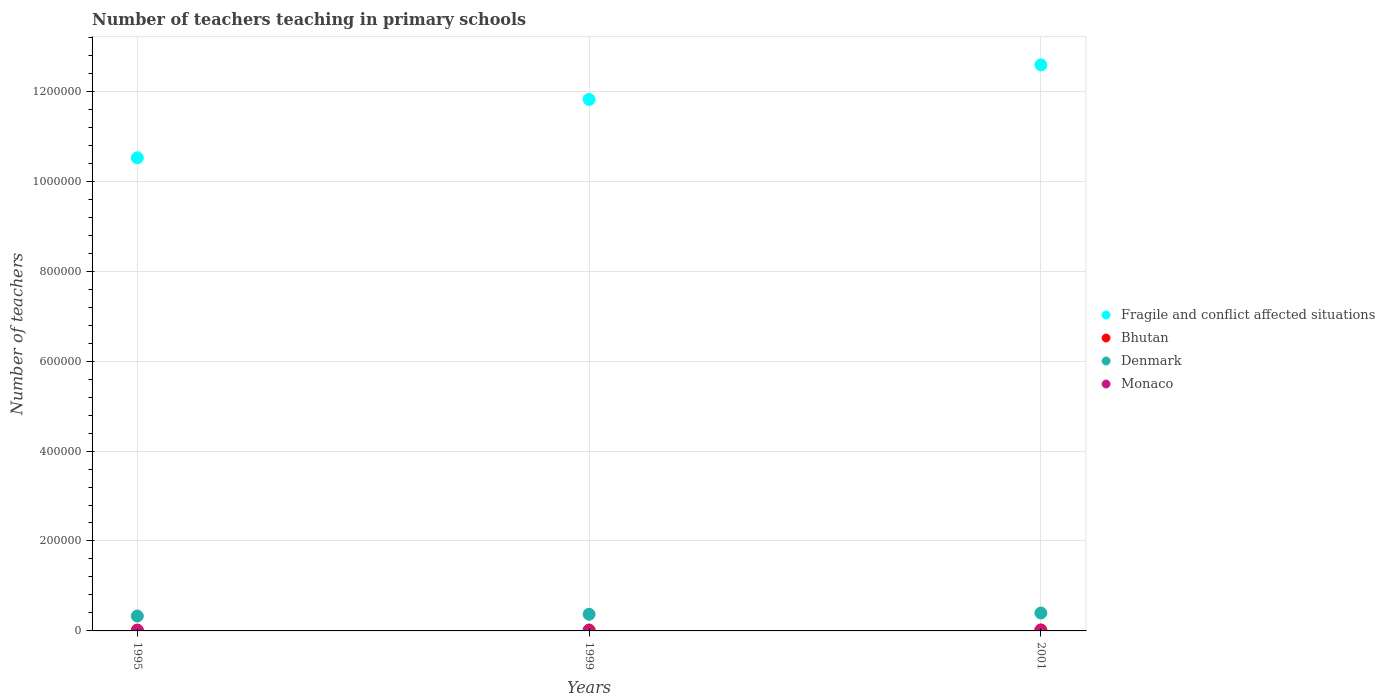How many different coloured dotlines are there?
Provide a succinct answer. 4. Is the number of dotlines equal to the number of legend labels?
Your answer should be compact. Yes. What is the number of teachers teaching in primary schools in Fragile and conflict affected situations in 1999?
Provide a short and direct response. 1.18e+06. Across all years, what is the maximum number of teachers teaching in primary schools in Bhutan?
Your answer should be very brief. 2234. Across all years, what is the minimum number of teachers teaching in primary schools in Bhutan?
Keep it short and to the point. 1829. In which year was the number of teachers teaching in primary schools in Monaco maximum?
Provide a short and direct response. 1995. In which year was the number of teachers teaching in primary schools in Fragile and conflict affected situations minimum?
Ensure brevity in your answer.  1995. What is the total number of teachers teaching in primary schools in Denmark in the graph?
Give a very brief answer. 1.10e+05. What is the difference between the number of teachers teaching in primary schools in Bhutan in 1999 and that in 2001?
Give a very brief answer. -288. What is the difference between the number of teachers teaching in primary schools in Monaco in 1995 and the number of teachers teaching in primary schools in Bhutan in 2001?
Your answer should be very brief. -2128. What is the average number of teachers teaching in primary schools in Fragile and conflict affected situations per year?
Offer a very short reply. 1.16e+06. In the year 1999, what is the difference between the number of teachers teaching in primary schools in Fragile and conflict affected situations and number of teachers teaching in primary schools in Denmark?
Make the answer very short. 1.14e+06. In how many years, is the number of teachers teaching in primary schools in Bhutan greater than 120000?
Your answer should be very brief. 0. What is the ratio of the number of teachers teaching in primary schools in Denmark in 1995 to that in 2001?
Keep it short and to the point. 0.83. Is the number of teachers teaching in primary schools in Denmark in 1995 less than that in 2001?
Your answer should be very brief. Yes. Is the difference between the number of teachers teaching in primary schools in Fragile and conflict affected situations in 1995 and 1999 greater than the difference between the number of teachers teaching in primary schools in Denmark in 1995 and 1999?
Ensure brevity in your answer.  No. What is the difference between the highest and the second highest number of teachers teaching in primary schools in Fragile and conflict affected situations?
Ensure brevity in your answer.  7.69e+04. What is the difference between the highest and the lowest number of teachers teaching in primary schools in Bhutan?
Your answer should be very brief. 405. In how many years, is the number of teachers teaching in primary schools in Monaco greater than the average number of teachers teaching in primary schools in Monaco taken over all years?
Keep it short and to the point. 1. Is it the case that in every year, the sum of the number of teachers teaching in primary schools in Bhutan and number of teachers teaching in primary schools in Denmark  is greater than the sum of number of teachers teaching in primary schools in Fragile and conflict affected situations and number of teachers teaching in primary schools in Monaco?
Provide a short and direct response. No. How many years are there in the graph?
Ensure brevity in your answer.  3. Are the values on the major ticks of Y-axis written in scientific E-notation?
Offer a very short reply. No. Does the graph contain any zero values?
Provide a short and direct response. No. Where does the legend appear in the graph?
Your answer should be very brief. Center right. What is the title of the graph?
Give a very brief answer. Number of teachers teaching in primary schools. What is the label or title of the Y-axis?
Ensure brevity in your answer.  Number of teachers. What is the Number of teachers of Fragile and conflict affected situations in 1995?
Offer a terse response. 1.05e+06. What is the Number of teachers of Bhutan in 1995?
Provide a succinct answer. 1829. What is the Number of teachers in Denmark in 1995?
Your response must be concise. 3.31e+04. What is the Number of teachers in Monaco in 1995?
Make the answer very short. 106. What is the Number of teachers in Fragile and conflict affected situations in 1999?
Give a very brief answer. 1.18e+06. What is the Number of teachers of Bhutan in 1999?
Ensure brevity in your answer.  1946. What is the Number of teachers in Denmark in 1999?
Your response must be concise. 3.70e+04. What is the Number of teachers of Monaco in 1999?
Provide a succinct answer. 90. What is the Number of teachers in Fragile and conflict affected situations in 2001?
Provide a short and direct response. 1.26e+06. What is the Number of teachers in Bhutan in 2001?
Provide a short and direct response. 2234. What is the Number of teachers in Denmark in 2001?
Your answer should be very brief. 3.99e+04. What is the Number of teachers in Monaco in 2001?
Offer a very short reply. 89. Across all years, what is the maximum Number of teachers in Fragile and conflict affected situations?
Keep it short and to the point. 1.26e+06. Across all years, what is the maximum Number of teachers in Bhutan?
Your response must be concise. 2234. Across all years, what is the maximum Number of teachers in Denmark?
Offer a very short reply. 3.99e+04. Across all years, what is the maximum Number of teachers of Monaco?
Offer a very short reply. 106. Across all years, what is the minimum Number of teachers of Fragile and conflict affected situations?
Offer a terse response. 1.05e+06. Across all years, what is the minimum Number of teachers of Bhutan?
Give a very brief answer. 1829. Across all years, what is the minimum Number of teachers in Denmark?
Your response must be concise. 3.31e+04. Across all years, what is the minimum Number of teachers of Monaco?
Provide a succinct answer. 89. What is the total Number of teachers of Fragile and conflict affected situations in the graph?
Offer a terse response. 3.49e+06. What is the total Number of teachers of Bhutan in the graph?
Your answer should be compact. 6009. What is the total Number of teachers in Denmark in the graph?
Provide a succinct answer. 1.10e+05. What is the total Number of teachers in Monaco in the graph?
Offer a terse response. 285. What is the difference between the Number of teachers of Fragile and conflict affected situations in 1995 and that in 1999?
Provide a short and direct response. -1.30e+05. What is the difference between the Number of teachers in Bhutan in 1995 and that in 1999?
Your answer should be very brief. -117. What is the difference between the Number of teachers in Denmark in 1995 and that in 1999?
Give a very brief answer. -3950. What is the difference between the Number of teachers of Monaco in 1995 and that in 1999?
Provide a short and direct response. 16. What is the difference between the Number of teachers in Fragile and conflict affected situations in 1995 and that in 2001?
Make the answer very short. -2.07e+05. What is the difference between the Number of teachers in Bhutan in 1995 and that in 2001?
Make the answer very short. -405. What is the difference between the Number of teachers of Denmark in 1995 and that in 2001?
Offer a very short reply. -6754. What is the difference between the Number of teachers of Fragile and conflict affected situations in 1999 and that in 2001?
Your response must be concise. -7.69e+04. What is the difference between the Number of teachers in Bhutan in 1999 and that in 2001?
Keep it short and to the point. -288. What is the difference between the Number of teachers in Denmark in 1999 and that in 2001?
Provide a succinct answer. -2804. What is the difference between the Number of teachers of Fragile and conflict affected situations in 1995 and the Number of teachers of Bhutan in 1999?
Your response must be concise. 1.05e+06. What is the difference between the Number of teachers in Fragile and conflict affected situations in 1995 and the Number of teachers in Denmark in 1999?
Provide a short and direct response. 1.01e+06. What is the difference between the Number of teachers of Fragile and conflict affected situations in 1995 and the Number of teachers of Monaco in 1999?
Your answer should be compact. 1.05e+06. What is the difference between the Number of teachers of Bhutan in 1995 and the Number of teachers of Denmark in 1999?
Offer a terse response. -3.52e+04. What is the difference between the Number of teachers of Bhutan in 1995 and the Number of teachers of Monaco in 1999?
Offer a terse response. 1739. What is the difference between the Number of teachers in Denmark in 1995 and the Number of teachers in Monaco in 1999?
Keep it short and to the point. 3.30e+04. What is the difference between the Number of teachers of Fragile and conflict affected situations in 1995 and the Number of teachers of Bhutan in 2001?
Your response must be concise. 1.05e+06. What is the difference between the Number of teachers in Fragile and conflict affected situations in 1995 and the Number of teachers in Denmark in 2001?
Ensure brevity in your answer.  1.01e+06. What is the difference between the Number of teachers of Fragile and conflict affected situations in 1995 and the Number of teachers of Monaco in 2001?
Keep it short and to the point. 1.05e+06. What is the difference between the Number of teachers of Bhutan in 1995 and the Number of teachers of Denmark in 2001?
Provide a succinct answer. -3.80e+04. What is the difference between the Number of teachers in Bhutan in 1995 and the Number of teachers in Monaco in 2001?
Keep it short and to the point. 1740. What is the difference between the Number of teachers in Denmark in 1995 and the Number of teachers in Monaco in 2001?
Your answer should be very brief. 3.30e+04. What is the difference between the Number of teachers in Fragile and conflict affected situations in 1999 and the Number of teachers in Bhutan in 2001?
Your response must be concise. 1.18e+06. What is the difference between the Number of teachers in Fragile and conflict affected situations in 1999 and the Number of teachers in Denmark in 2001?
Your response must be concise. 1.14e+06. What is the difference between the Number of teachers in Fragile and conflict affected situations in 1999 and the Number of teachers in Monaco in 2001?
Offer a terse response. 1.18e+06. What is the difference between the Number of teachers in Bhutan in 1999 and the Number of teachers in Denmark in 2001?
Your response must be concise. -3.79e+04. What is the difference between the Number of teachers of Bhutan in 1999 and the Number of teachers of Monaco in 2001?
Give a very brief answer. 1857. What is the difference between the Number of teachers of Denmark in 1999 and the Number of teachers of Monaco in 2001?
Give a very brief answer. 3.70e+04. What is the average Number of teachers of Fragile and conflict affected situations per year?
Give a very brief answer. 1.16e+06. What is the average Number of teachers in Bhutan per year?
Give a very brief answer. 2003. What is the average Number of teachers of Denmark per year?
Offer a terse response. 3.67e+04. What is the average Number of teachers of Monaco per year?
Your answer should be very brief. 95. In the year 1995, what is the difference between the Number of teachers of Fragile and conflict affected situations and Number of teachers of Bhutan?
Your answer should be compact. 1.05e+06. In the year 1995, what is the difference between the Number of teachers in Fragile and conflict affected situations and Number of teachers in Denmark?
Your answer should be compact. 1.02e+06. In the year 1995, what is the difference between the Number of teachers in Fragile and conflict affected situations and Number of teachers in Monaco?
Your response must be concise. 1.05e+06. In the year 1995, what is the difference between the Number of teachers in Bhutan and Number of teachers in Denmark?
Provide a short and direct response. -3.13e+04. In the year 1995, what is the difference between the Number of teachers of Bhutan and Number of teachers of Monaco?
Your answer should be compact. 1723. In the year 1995, what is the difference between the Number of teachers in Denmark and Number of teachers in Monaco?
Your answer should be compact. 3.30e+04. In the year 1999, what is the difference between the Number of teachers in Fragile and conflict affected situations and Number of teachers in Bhutan?
Provide a short and direct response. 1.18e+06. In the year 1999, what is the difference between the Number of teachers of Fragile and conflict affected situations and Number of teachers of Denmark?
Ensure brevity in your answer.  1.14e+06. In the year 1999, what is the difference between the Number of teachers in Fragile and conflict affected situations and Number of teachers in Monaco?
Provide a succinct answer. 1.18e+06. In the year 1999, what is the difference between the Number of teachers in Bhutan and Number of teachers in Denmark?
Offer a very short reply. -3.51e+04. In the year 1999, what is the difference between the Number of teachers in Bhutan and Number of teachers in Monaco?
Ensure brevity in your answer.  1856. In the year 1999, what is the difference between the Number of teachers of Denmark and Number of teachers of Monaco?
Offer a terse response. 3.70e+04. In the year 2001, what is the difference between the Number of teachers in Fragile and conflict affected situations and Number of teachers in Bhutan?
Your answer should be compact. 1.26e+06. In the year 2001, what is the difference between the Number of teachers in Fragile and conflict affected situations and Number of teachers in Denmark?
Your answer should be very brief. 1.22e+06. In the year 2001, what is the difference between the Number of teachers of Fragile and conflict affected situations and Number of teachers of Monaco?
Give a very brief answer. 1.26e+06. In the year 2001, what is the difference between the Number of teachers of Bhutan and Number of teachers of Denmark?
Make the answer very short. -3.76e+04. In the year 2001, what is the difference between the Number of teachers in Bhutan and Number of teachers in Monaco?
Give a very brief answer. 2145. In the year 2001, what is the difference between the Number of teachers of Denmark and Number of teachers of Monaco?
Your answer should be compact. 3.98e+04. What is the ratio of the Number of teachers in Fragile and conflict affected situations in 1995 to that in 1999?
Keep it short and to the point. 0.89. What is the ratio of the Number of teachers in Bhutan in 1995 to that in 1999?
Provide a short and direct response. 0.94. What is the ratio of the Number of teachers of Denmark in 1995 to that in 1999?
Your answer should be very brief. 0.89. What is the ratio of the Number of teachers in Monaco in 1995 to that in 1999?
Give a very brief answer. 1.18. What is the ratio of the Number of teachers of Fragile and conflict affected situations in 1995 to that in 2001?
Ensure brevity in your answer.  0.84. What is the ratio of the Number of teachers in Bhutan in 1995 to that in 2001?
Your answer should be compact. 0.82. What is the ratio of the Number of teachers in Denmark in 1995 to that in 2001?
Your answer should be very brief. 0.83. What is the ratio of the Number of teachers of Monaco in 1995 to that in 2001?
Your answer should be compact. 1.19. What is the ratio of the Number of teachers of Fragile and conflict affected situations in 1999 to that in 2001?
Keep it short and to the point. 0.94. What is the ratio of the Number of teachers in Bhutan in 1999 to that in 2001?
Ensure brevity in your answer.  0.87. What is the ratio of the Number of teachers of Denmark in 1999 to that in 2001?
Your answer should be compact. 0.93. What is the ratio of the Number of teachers in Monaco in 1999 to that in 2001?
Ensure brevity in your answer.  1.01. What is the difference between the highest and the second highest Number of teachers of Fragile and conflict affected situations?
Your answer should be compact. 7.69e+04. What is the difference between the highest and the second highest Number of teachers of Bhutan?
Offer a very short reply. 288. What is the difference between the highest and the second highest Number of teachers in Denmark?
Keep it short and to the point. 2804. What is the difference between the highest and the lowest Number of teachers of Fragile and conflict affected situations?
Give a very brief answer. 2.07e+05. What is the difference between the highest and the lowest Number of teachers in Bhutan?
Your answer should be compact. 405. What is the difference between the highest and the lowest Number of teachers in Denmark?
Offer a terse response. 6754. 